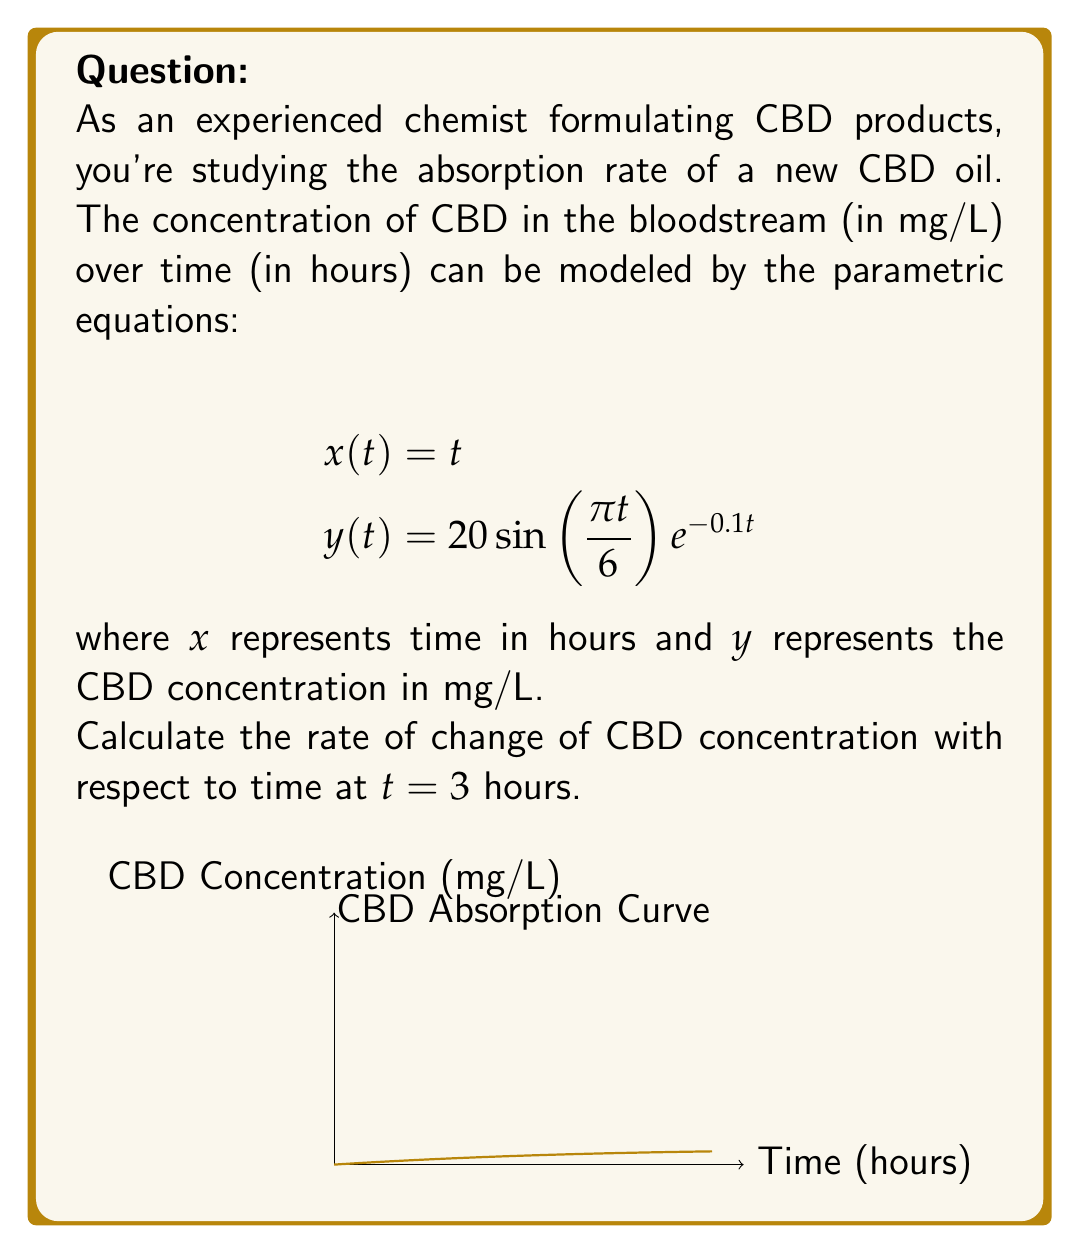Provide a solution to this math problem. To solve this problem, we need to find $\frac{dy}{dx}$ at $t = 3$ hours. Since we have parametric equations, we'll use the chain rule:

$$\frac{dy}{dx} = \frac{dy/dt}{dx/dt}$$

Step 1: Find $\frac{dx}{dt}$
$$\frac{dx}{dt} = 1$$ (since $x(t) = t$)

Step 2: Find $\frac{dy}{dt}$
$$\begin{align}
\frac{dy}{dt} &= \frac{d}{dt}[20\sin(\frac{\pi t}{6})e^{-0.1t}] \\
&= 20[\frac{\pi}{6}\cos(\frac{\pi t}{6})e^{-0.1t} + \sin(\frac{\pi t}{6})(-0.1e^{-0.1t})] \\
&= 20e^{-0.1t}[\frac{\pi}{6}\cos(\frac{\pi t}{6}) - 0.1\sin(\frac{\pi t}{6})]
\end{align}$$

Step 3: Calculate $\frac{dy}{dx}$ at $t = 3$
$$\begin{align}
\frac{dy}{dx}\bigg|_{t=3} &= \frac{dy/dt}{dx/dt}\bigg|_{t=3} \\
&= 20e^{-0.1(3)}[\frac{\pi}{6}\cos(\frac{\pi (3)}{6}) - 0.1\sin(\frac{\pi (3)}{6})] \\
&= 20e^{-0.3}[\frac{\pi}{6}\cos(\frac{\pi}{2}) - 0.1\sin(\frac{\pi}{2})] \\
&= 20e^{-0.3}[0 - 0.1] \\
&= -2e^{-0.3}
\end{align}$$

Step 4: Simplify the result
$$\frac{dy}{dx}\bigg|_{t=3} \approx -1.48 \text{ mg/L/hour}$$
Answer: $-1.48$ mg/L/hour 